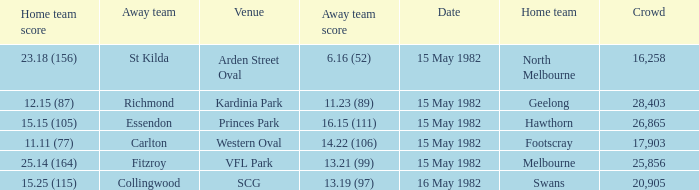Which home team played against the away team with a score of 13.19 (97)? Swans. 